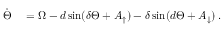Convert formula to latex. <formula><loc_0><loc_0><loc_500><loc_500>\begin{array} { r l } { \ D o t { \Theta } } & = \Omega - d \sin ( \delta \Theta + A _ { \uparrow } ) - \delta \sin ( d \Theta + A _ { \downarrow } ) \, . } \end{array}</formula> 